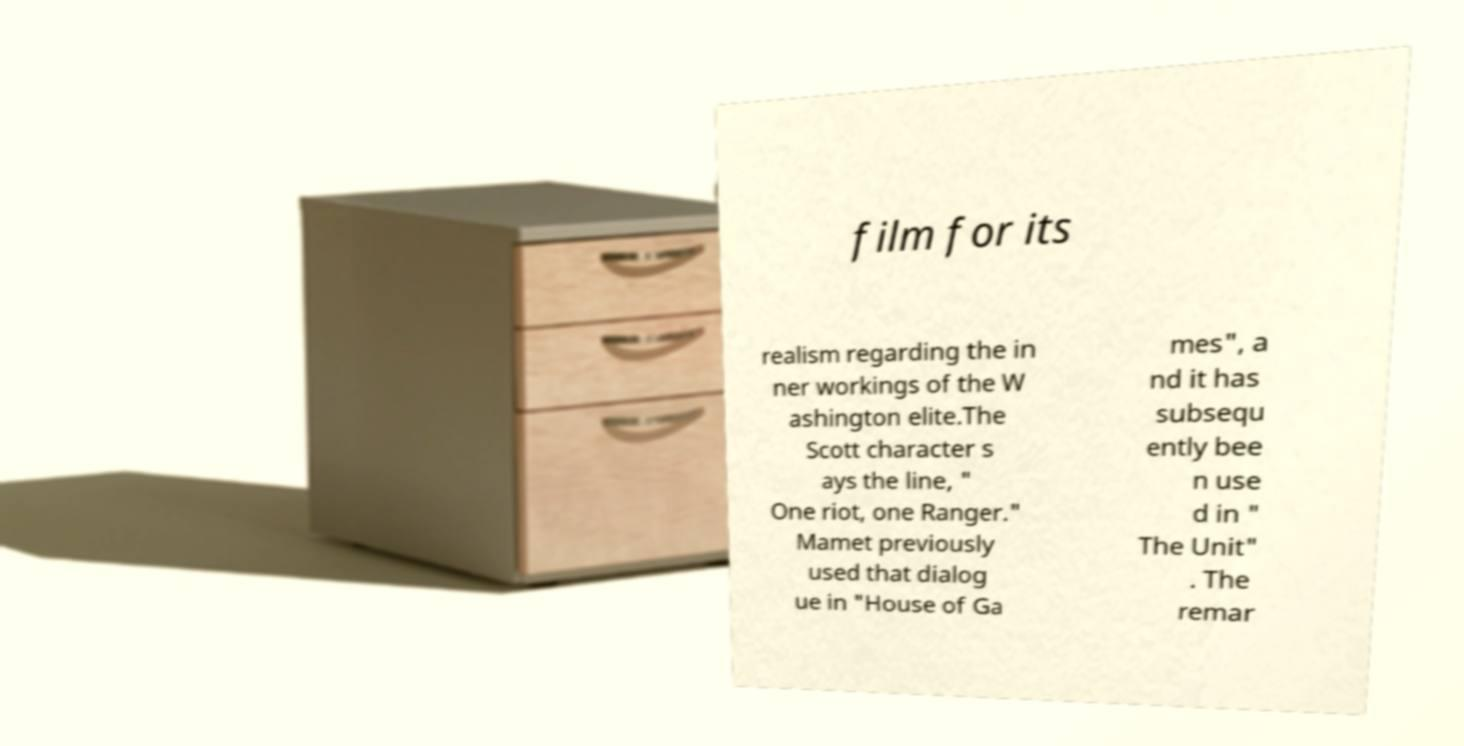Please read and relay the text visible in this image. What does it say? film for its realism regarding the in ner workings of the W ashington elite.The Scott character s ays the line, " One riot, one Ranger." Mamet previously used that dialog ue in "House of Ga mes", a nd it has subsequ ently bee n use d in " The Unit" . The remar 